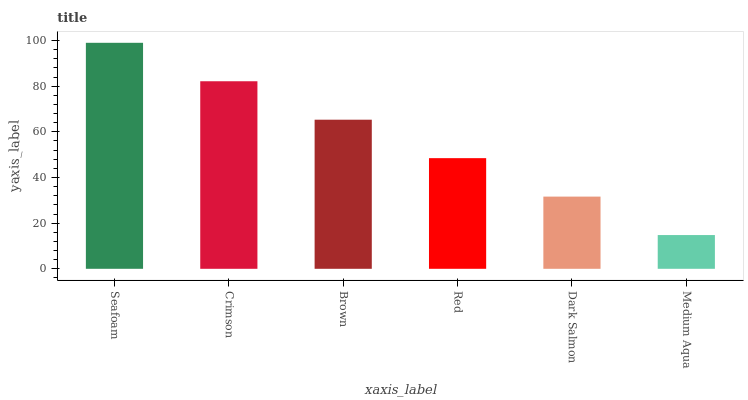Is Medium Aqua the minimum?
Answer yes or no. Yes. Is Seafoam the maximum?
Answer yes or no. Yes. Is Crimson the minimum?
Answer yes or no. No. Is Crimson the maximum?
Answer yes or no. No. Is Seafoam greater than Crimson?
Answer yes or no. Yes. Is Crimson less than Seafoam?
Answer yes or no. Yes. Is Crimson greater than Seafoam?
Answer yes or no. No. Is Seafoam less than Crimson?
Answer yes or no. No. Is Brown the high median?
Answer yes or no. Yes. Is Red the low median?
Answer yes or no. Yes. Is Dark Salmon the high median?
Answer yes or no. No. Is Crimson the low median?
Answer yes or no. No. 